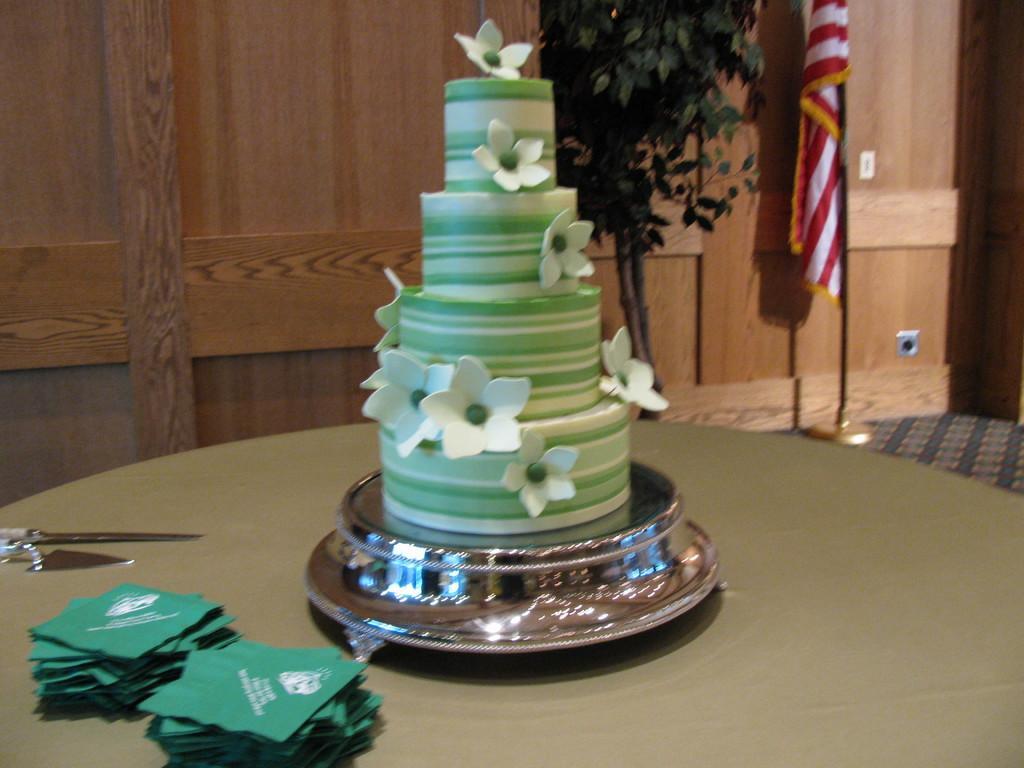Please provide a concise description of this image. In this image I can see a cake, a knife and other objects on a table. In the background I can see a flag and a wall. 